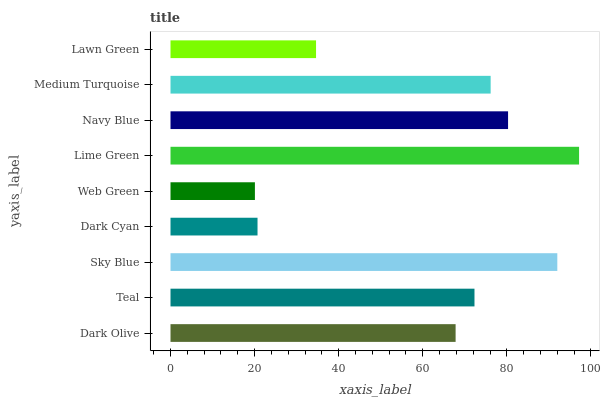Is Web Green the minimum?
Answer yes or no. Yes. Is Lime Green the maximum?
Answer yes or no. Yes. Is Teal the minimum?
Answer yes or no. No. Is Teal the maximum?
Answer yes or no. No. Is Teal greater than Dark Olive?
Answer yes or no. Yes. Is Dark Olive less than Teal?
Answer yes or no. Yes. Is Dark Olive greater than Teal?
Answer yes or no. No. Is Teal less than Dark Olive?
Answer yes or no. No. Is Teal the high median?
Answer yes or no. Yes. Is Teal the low median?
Answer yes or no. Yes. Is Navy Blue the high median?
Answer yes or no. No. Is Lawn Green the low median?
Answer yes or no. No. 